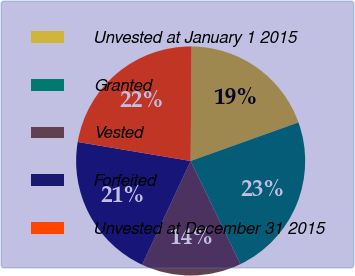Convert chart to OTSL. <chart><loc_0><loc_0><loc_500><loc_500><pie_chart><fcel>Unvested at January 1 2015<fcel>Granted<fcel>Vested<fcel>Forfeited<fcel>Unvested at December 31 2015<nl><fcel>19.41%<fcel>23.31%<fcel>14.12%<fcel>20.69%<fcel>22.47%<nl></chart> 